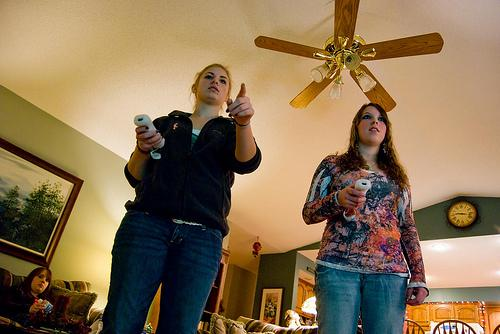For the visual entailment task, describe any significant hair features of the two main subjects in the image. One woman has blonde hair, and the other woman has dark hair. In this image, can you identify any objects related to the entertainment of the main subjects? Yes, the image has two Wii video game controllers, which the young women are using to play the game. What kind of clothing is one of the women wearing, and what is the state of the other woman's jeans? One woman is wearing a multicolored long-sleeved shirt, and the other woman's jeans are stonewashed. From a low angle perspective, how many people can be seen in the image? Two young women can be seen in the image from a low angle perspective. Could you mention some furniture and decoration items shown in this image? A striped sofa, a chair with a wooden back, a framed artwork print with trees, a wall-mounted clock, and a ceiling fan with light are present in the image. What are the two subjects holding in their hands, and what color are the objects? The two subjects are holding white Wii game controllers in their hands. For the multi-choice VQA task, choose the most accurate description of the wall color in the image. The wall is painted green. Briefly explain a key component of the environment in which the main subjects are situated for the product advertisement task. The two friends are playing a Wii video game in a cozy living room with a striped sofa and a green painted wall, creating a fun and relaxed atmosphere. What kind of activity are the two main subjects in the image engaging in? The two main subjects are young women playing a video game, specifically Wii. For the referential expression grounding task, describe the location of an artwork in the image. A framed artwork print, presumably depicting trees in a forest, is hanging on the wall near the top-left corner of the image. 